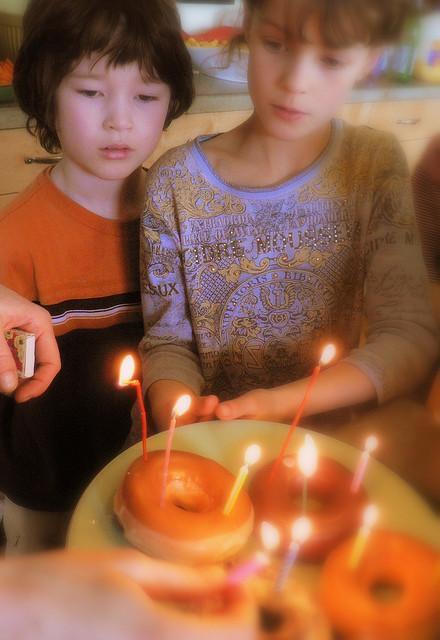How many candles?
Give a very brief answer. 9. How many people are visible?
Give a very brief answer. 3. How many donuts are in the photo?
Give a very brief answer. 4. How many birds are there?
Give a very brief answer. 0. 